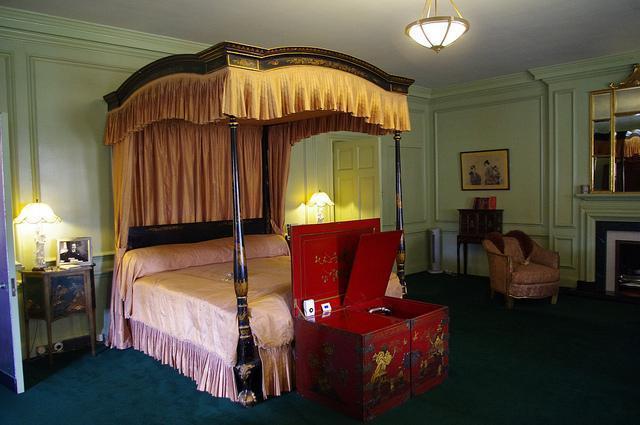How many beds are there?
Give a very brief answer. 1. 